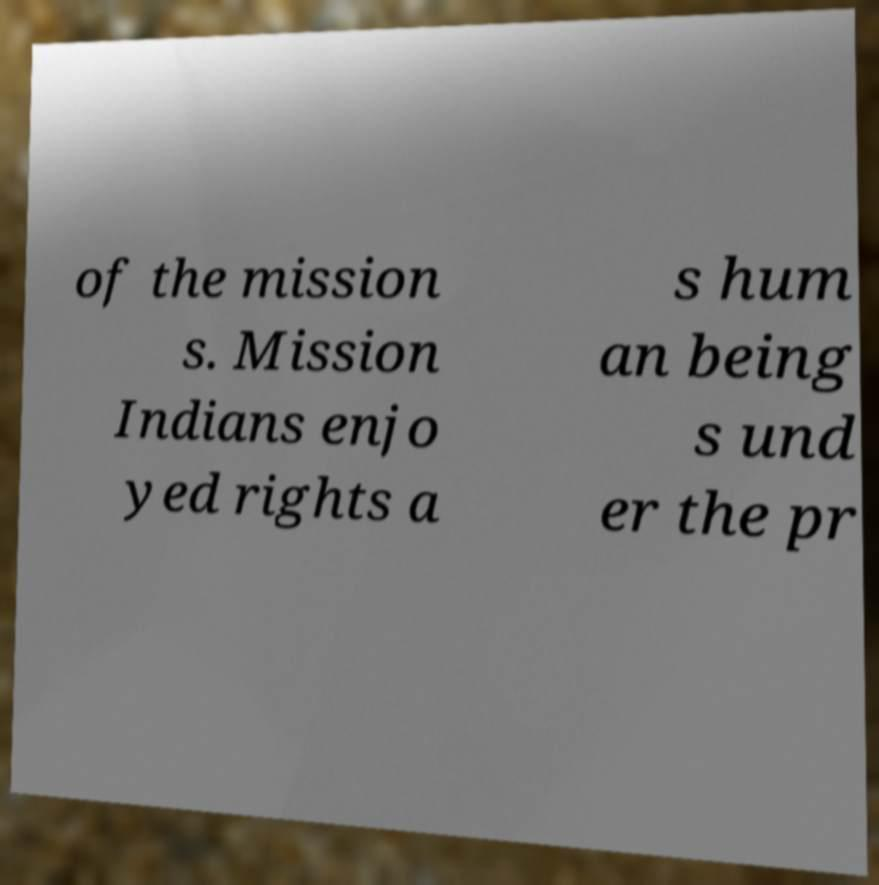For documentation purposes, I need the text within this image transcribed. Could you provide that? of the mission s. Mission Indians enjo yed rights a s hum an being s und er the pr 